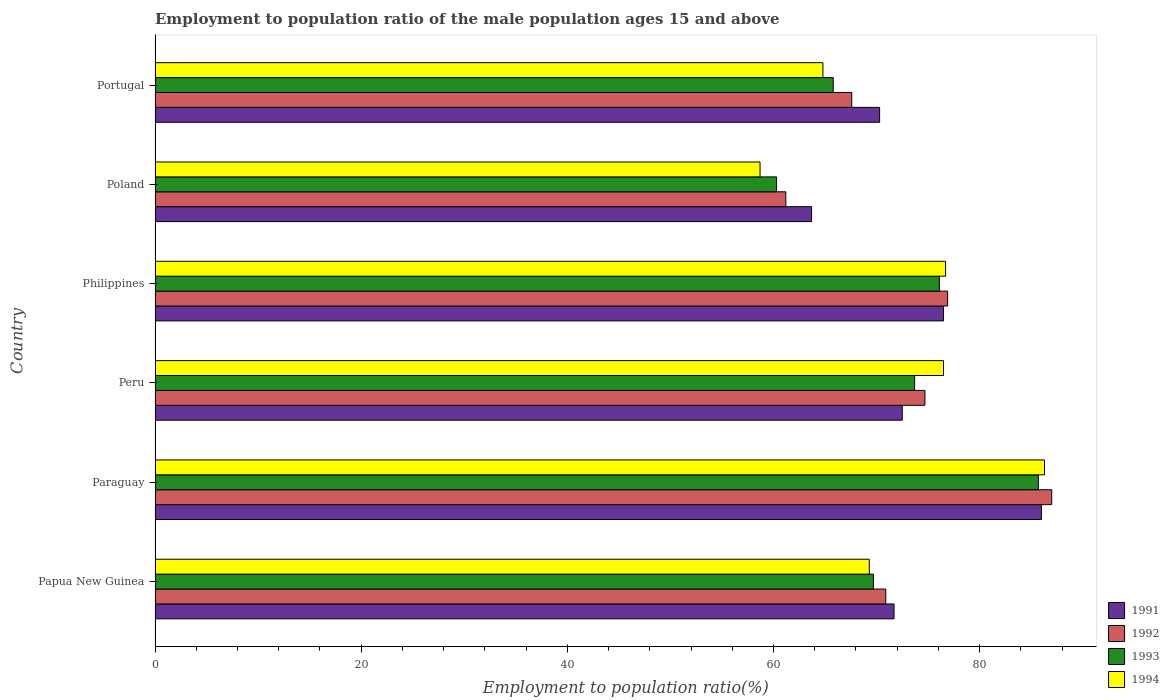How many different coloured bars are there?
Ensure brevity in your answer.  4. How many groups of bars are there?
Offer a terse response. 6. Are the number of bars on each tick of the Y-axis equal?
Offer a terse response. Yes. What is the employment to population ratio in 1993 in Paraguay?
Offer a terse response. 85.7. Across all countries, what is the maximum employment to population ratio in 1994?
Ensure brevity in your answer.  86.3. Across all countries, what is the minimum employment to population ratio in 1994?
Keep it short and to the point. 58.7. In which country was the employment to population ratio in 1991 maximum?
Your answer should be very brief. Paraguay. In which country was the employment to population ratio in 1991 minimum?
Offer a very short reply. Poland. What is the total employment to population ratio in 1991 in the graph?
Offer a terse response. 440.7. What is the difference between the employment to population ratio in 1993 in Papua New Guinea and that in Philippines?
Give a very brief answer. -6.4. What is the difference between the employment to population ratio in 1994 in Paraguay and the employment to population ratio in 1993 in Peru?
Offer a very short reply. 12.6. What is the average employment to population ratio in 1994 per country?
Keep it short and to the point. 72.05. What is the difference between the employment to population ratio in 1993 and employment to population ratio in 1991 in Peru?
Offer a terse response. 1.2. What is the ratio of the employment to population ratio in 1994 in Peru to that in Portugal?
Ensure brevity in your answer.  1.18. Is the difference between the employment to population ratio in 1993 in Papua New Guinea and Poland greater than the difference between the employment to population ratio in 1991 in Papua New Guinea and Poland?
Your response must be concise. Yes. What is the difference between the highest and the second highest employment to population ratio in 1991?
Provide a short and direct response. 9.5. What is the difference between the highest and the lowest employment to population ratio in 1992?
Make the answer very short. 25.8. In how many countries, is the employment to population ratio in 1994 greater than the average employment to population ratio in 1994 taken over all countries?
Provide a succinct answer. 3. Is it the case that in every country, the sum of the employment to population ratio in 1991 and employment to population ratio in 1994 is greater than the sum of employment to population ratio in 1992 and employment to population ratio in 1993?
Ensure brevity in your answer.  No. What does the 1st bar from the bottom in Peru represents?
Provide a short and direct response. 1991. Is it the case that in every country, the sum of the employment to population ratio in 1991 and employment to population ratio in 1993 is greater than the employment to population ratio in 1994?
Offer a terse response. Yes. Does the graph contain any zero values?
Offer a terse response. No. Does the graph contain grids?
Make the answer very short. No. What is the title of the graph?
Offer a terse response. Employment to population ratio of the male population ages 15 and above. What is the label or title of the X-axis?
Your answer should be very brief. Employment to population ratio(%). What is the label or title of the Y-axis?
Provide a short and direct response. Country. What is the Employment to population ratio(%) of 1991 in Papua New Guinea?
Your answer should be compact. 71.7. What is the Employment to population ratio(%) of 1992 in Papua New Guinea?
Offer a very short reply. 70.9. What is the Employment to population ratio(%) of 1993 in Papua New Guinea?
Offer a very short reply. 69.7. What is the Employment to population ratio(%) of 1994 in Papua New Guinea?
Your answer should be very brief. 69.3. What is the Employment to population ratio(%) of 1991 in Paraguay?
Offer a terse response. 86. What is the Employment to population ratio(%) of 1993 in Paraguay?
Your answer should be compact. 85.7. What is the Employment to population ratio(%) of 1994 in Paraguay?
Give a very brief answer. 86.3. What is the Employment to population ratio(%) in 1991 in Peru?
Your response must be concise. 72.5. What is the Employment to population ratio(%) in 1992 in Peru?
Offer a very short reply. 74.7. What is the Employment to population ratio(%) of 1993 in Peru?
Make the answer very short. 73.7. What is the Employment to population ratio(%) of 1994 in Peru?
Make the answer very short. 76.5. What is the Employment to population ratio(%) in 1991 in Philippines?
Offer a terse response. 76.5. What is the Employment to population ratio(%) in 1992 in Philippines?
Offer a very short reply. 76.9. What is the Employment to population ratio(%) of 1993 in Philippines?
Provide a succinct answer. 76.1. What is the Employment to population ratio(%) in 1994 in Philippines?
Offer a very short reply. 76.7. What is the Employment to population ratio(%) of 1991 in Poland?
Ensure brevity in your answer.  63.7. What is the Employment to population ratio(%) of 1992 in Poland?
Offer a very short reply. 61.2. What is the Employment to population ratio(%) of 1993 in Poland?
Keep it short and to the point. 60.3. What is the Employment to population ratio(%) in 1994 in Poland?
Give a very brief answer. 58.7. What is the Employment to population ratio(%) in 1991 in Portugal?
Offer a terse response. 70.3. What is the Employment to population ratio(%) in 1992 in Portugal?
Offer a very short reply. 67.6. What is the Employment to population ratio(%) of 1993 in Portugal?
Provide a succinct answer. 65.8. What is the Employment to population ratio(%) in 1994 in Portugal?
Keep it short and to the point. 64.8. Across all countries, what is the maximum Employment to population ratio(%) in 1991?
Your answer should be compact. 86. Across all countries, what is the maximum Employment to population ratio(%) of 1992?
Your answer should be very brief. 87. Across all countries, what is the maximum Employment to population ratio(%) of 1993?
Provide a succinct answer. 85.7. Across all countries, what is the maximum Employment to population ratio(%) in 1994?
Offer a terse response. 86.3. Across all countries, what is the minimum Employment to population ratio(%) in 1991?
Make the answer very short. 63.7. Across all countries, what is the minimum Employment to population ratio(%) of 1992?
Your answer should be very brief. 61.2. Across all countries, what is the minimum Employment to population ratio(%) in 1993?
Provide a short and direct response. 60.3. Across all countries, what is the minimum Employment to population ratio(%) of 1994?
Give a very brief answer. 58.7. What is the total Employment to population ratio(%) of 1991 in the graph?
Keep it short and to the point. 440.7. What is the total Employment to population ratio(%) in 1992 in the graph?
Give a very brief answer. 438.3. What is the total Employment to population ratio(%) of 1993 in the graph?
Make the answer very short. 431.3. What is the total Employment to population ratio(%) of 1994 in the graph?
Give a very brief answer. 432.3. What is the difference between the Employment to population ratio(%) of 1991 in Papua New Guinea and that in Paraguay?
Offer a terse response. -14.3. What is the difference between the Employment to population ratio(%) of 1992 in Papua New Guinea and that in Paraguay?
Your answer should be very brief. -16.1. What is the difference between the Employment to population ratio(%) of 1993 in Papua New Guinea and that in Paraguay?
Your answer should be compact. -16. What is the difference between the Employment to population ratio(%) of 1991 in Papua New Guinea and that in Peru?
Give a very brief answer. -0.8. What is the difference between the Employment to population ratio(%) of 1994 in Papua New Guinea and that in Peru?
Provide a succinct answer. -7.2. What is the difference between the Employment to population ratio(%) of 1991 in Papua New Guinea and that in Philippines?
Give a very brief answer. -4.8. What is the difference between the Employment to population ratio(%) of 1994 in Papua New Guinea and that in Philippines?
Provide a succinct answer. -7.4. What is the difference between the Employment to population ratio(%) in 1991 in Papua New Guinea and that in Poland?
Provide a succinct answer. 8. What is the difference between the Employment to population ratio(%) of 1993 in Papua New Guinea and that in Poland?
Your response must be concise. 9.4. What is the difference between the Employment to population ratio(%) of 1994 in Papua New Guinea and that in Poland?
Your answer should be compact. 10.6. What is the difference between the Employment to population ratio(%) in 1991 in Papua New Guinea and that in Portugal?
Offer a terse response. 1.4. What is the difference between the Employment to population ratio(%) in 1992 in Papua New Guinea and that in Portugal?
Your response must be concise. 3.3. What is the difference between the Employment to population ratio(%) of 1991 in Paraguay and that in Peru?
Your answer should be compact. 13.5. What is the difference between the Employment to population ratio(%) of 1992 in Paraguay and that in Peru?
Your response must be concise. 12.3. What is the difference between the Employment to population ratio(%) in 1991 in Paraguay and that in Philippines?
Keep it short and to the point. 9.5. What is the difference between the Employment to population ratio(%) of 1991 in Paraguay and that in Poland?
Keep it short and to the point. 22.3. What is the difference between the Employment to population ratio(%) in 1992 in Paraguay and that in Poland?
Offer a very short reply. 25.8. What is the difference between the Employment to population ratio(%) in 1993 in Paraguay and that in Poland?
Give a very brief answer. 25.4. What is the difference between the Employment to population ratio(%) of 1994 in Paraguay and that in Poland?
Your response must be concise. 27.6. What is the difference between the Employment to population ratio(%) of 1993 in Paraguay and that in Portugal?
Your answer should be compact. 19.9. What is the difference between the Employment to population ratio(%) in 1994 in Paraguay and that in Portugal?
Ensure brevity in your answer.  21.5. What is the difference between the Employment to population ratio(%) of 1991 in Peru and that in Philippines?
Offer a terse response. -4. What is the difference between the Employment to population ratio(%) in 1991 in Peru and that in Poland?
Keep it short and to the point. 8.8. What is the difference between the Employment to population ratio(%) of 1992 in Peru and that in Poland?
Your answer should be very brief. 13.5. What is the difference between the Employment to population ratio(%) in 1991 in Peru and that in Portugal?
Your response must be concise. 2.2. What is the difference between the Employment to population ratio(%) of 1994 in Peru and that in Portugal?
Your response must be concise. 11.7. What is the difference between the Employment to population ratio(%) of 1991 in Philippines and that in Portugal?
Provide a succinct answer. 6.2. What is the difference between the Employment to population ratio(%) in 1993 in Philippines and that in Portugal?
Ensure brevity in your answer.  10.3. What is the difference between the Employment to population ratio(%) in 1993 in Poland and that in Portugal?
Offer a terse response. -5.5. What is the difference between the Employment to population ratio(%) of 1991 in Papua New Guinea and the Employment to population ratio(%) of 1992 in Paraguay?
Provide a short and direct response. -15.3. What is the difference between the Employment to population ratio(%) in 1991 in Papua New Guinea and the Employment to population ratio(%) in 1993 in Paraguay?
Provide a short and direct response. -14. What is the difference between the Employment to population ratio(%) of 1991 in Papua New Guinea and the Employment to population ratio(%) of 1994 in Paraguay?
Provide a short and direct response. -14.6. What is the difference between the Employment to population ratio(%) of 1992 in Papua New Guinea and the Employment to population ratio(%) of 1993 in Paraguay?
Your answer should be compact. -14.8. What is the difference between the Employment to population ratio(%) in 1992 in Papua New Guinea and the Employment to population ratio(%) in 1994 in Paraguay?
Provide a short and direct response. -15.4. What is the difference between the Employment to population ratio(%) of 1993 in Papua New Guinea and the Employment to population ratio(%) of 1994 in Paraguay?
Your answer should be very brief. -16.6. What is the difference between the Employment to population ratio(%) in 1991 in Papua New Guinea and the Employment to population ratio(%) in 1992 in Peru?
Your response must be concise. -3. What is the difference between the Employment to population ratio(%) of 1992 in Papua New Guinea and the Employment to population ratio(%) of 1994 in Peru?
Your answer should be compact. -5.6. What is the difference between the Employment to population ratio(%) of 1993 in Papua New Guinea and the Employment to population ratio(%) of 1994 in Peru?
Give a very brief answer. -6.8. What is the difference between the Employment to population ratio(%) in 1991 in Papua New Guinea and the Employment to population ratio(%) in 1993 in Philippines?
Your response must be concise. -4.4. What is the difference between the Employment to population ratio(%) of 1991 in Papua New Guinea and the Employment to population ratio(%) of 1992 in Poland?
Offer a very short reply. 10.5. What is the difference between the Employment to population ratio(%) in 1992 in Papua New Guinea and the Employment to population ratio(%) in 1993 in Poland?
Give a very brief answer. 10.6. What is the difference between the Employment to population ratio(%) in 1991 in Papua New Guinea and the Employment to population ratio(%) in 1993 in Portugal?
Provide a short and direct response. 5.9. What is the difference between the Employment to population ratio(%) of 1991 in Papua New Guinea and the Employment to population ratio(%) of 1994 in Portugal?
Offer a terse response. 6.9. What is the difference between the Employment to population ratio(%) of 1992 in Papua New Guinea and the Employment to population ratio(%) of 1994 in Portugal?
Your response must be concise. 6.1. What is the difference between the Employment to population ratio(%) in 1991 in Paraguay and the Employment to population ratio(%) in 1992 in Peru?
Give a very brief answer. 11.3. What is the difference between the Employment to population ratio(%) in 1991 in Paraguay and the Employment to population ratio(%) in 1993 in Peru?
Your answer should be compact. 12.3. What is the difference between the Employment to population ratio(%) in 1992 in Paraguay and the Employment to population ratio(%) in 1994 in Peru?
Offer a terse response. 10.5. What is the difference between the Employment to population ratio(%) of 1991 in Paraguay and the Employment to population ratio(%) of 1992 in Philippines?
Provide a short and direct response. 9.1. What is the difference between the Employment to population ratio(%) in 1991 in Paraguay and the Employment to population ratio(%) in 1993 in Philippines?
Offer a terse response. 9.9. What is the difference between the Employment to population ratio(%) of 1991 in Paraguay and the Employment to population ratio(%) of 1994 in Philippines?
Provide a succinct answer. 9.3. What is the difference between the Employment to population ratio(%) of 1992 in Paraguay and the Employment to population ratio(%) of 1993 in Philippines?
Your response must be concise. 10.9. What is the difference between the Employment to population ratio(%) of 1992 in Paraguay and the Employment to population ratio(%) of 1994 in Philippines?
Offer a terse response. 10.3. What is the difference between the Employment to population ratio(%) in 1993 in Paraguay and the Employment to population ratio(%) in 1994 in Philippines?
Give a very brief answer. 9. What is the difference between the Employment to population ratio(%) in 1991 in Paraguay and the Employment to population ratio(%) in 1992 in Poland?
Your response must be concise. 24.8. What is the difference between the Employment to population ratio(%) in 1991 in Paraguay and the Employment to population ratio(%) in 1993 in Poland?
Ensure brevity in your answer.  25.7. What is the difference between the Employment to population ratio(%) in 1991 in Paraguay and the Employment to population ratio(%) in 1994 in Poland?
Offer a terse response. 27.3. What is the difference between the Employment to population ratio(%) of 1992 in Paraguay and the Employment to population ratio(%) of 1993 in Poland?
Your response must be concise. 26.7. What is the difference between the Employment to population ratio(%) in 1992 in Paraguay and the Employment to population ratio(%) in 1994 in Poland?
Keep it short and to the point. 28.3. What is the difference between the Employment to population ratio(%) of 1993 in Paraguay and the Employment to population ratio(%) of 1994 in Poland?
Give a very brief answer. 27. What is the difference between the Employment to population ratio(%) of 1991 in Paraguay and the Employment to population ratio(%) of 1993 in Portugal?
Offer a terse response. 20.2. What is the difference between the Employment to population ratio(%) in 1991 in Paraguay and the Employment to population ratio(%) in 1994 in Portugal?
Give a very brief answer. 21.2. What is the difference between the Employment to population ratio(%) of 1992 in Paraguay and the Employment to population ratio(%) of 1993 in Portugal?
Offer a very short reply. 21.2. What is the difference between the Employment to population ratio(%) of 1993 in Paraguay and the Employment to population ratio(%) of 1994 in Portugal?
Make the answer very short. 20.9. What is the difference between the Employment to population ratio(%) of 1991 in Peru and the Employment to population ratio(%) of 1994 in Philippines?
Provide a succinct answer. -4.2. What is the difference between the Employment to population ratio(%) of 1992 in Peru and the Employment to population ratio(%) of 1994 in Philippines?
Keep it short and to the point. -2. What is the difference between the Employment to population ratio(%) in 1991 in Peru and the Employment to population ratio(%) in 1993 in Poland?
Provide a short and direct response. 12.2. What is the difference between the Employment to population ratio(%) in 1991 in Peru and the Employment to population ratio(%) in 1994 in Poland?
Provide a short and direct response. 13.8. What is the difference between the Employment to population ratio(%) in 1992 in Peru and the Employment to population ratio(%) in 1994 in Poland?
Your answer should be very brief. 16. What is the difference between the Employment to population ratio(%) of 1993 in Peru and the Employment to population ratio(%) of 1994 in Poland?
Offer a terse response. 15. What is the difference between the Employment to population ratio(%) in 1991 in Peru and the Employment to population ratio(%) in 1992 in Portugal?
Offer a very short reply. 4.9. What is the difference between the Employment to population ratio(%) of 1991 in Peru and the Employment to population ratio(%) of 1994 in Portugal?
Make the answer very short. 7.7. What is the difference between the Employment to population ratio(%) in 1993 in Peru and the Employment to population ratio(%) in 1994 in Portugal?
Make the answer very short. 8.9. What is the difference between the Employment to population ratio(%) of 1991 in Philippines and the Employment to population ratio(%) of 1993 in Poland?
Offer a very short reply. 16.2. What is the difference between the Employment to population ratio(%) in 1991 in Philippines and the Employment to population ratio(%) in 1994 in Poland?
Keep it short and to the point. 17.8. What is the difference between the Employment to population ratio(%) of 1992 in Philippines and the Employment to population ratio(%) of 1993 in Poland?
Provide a short and direct response. 16.6. What is the difference between the Employment to population ratio(%) of 1992 in Philippines and the Employment to population ratio(%) of 1994 in Poland?
Make the answer very short. 18.2. What is the difference between the Employment to population ratio(%) in 1991 in Philippines and the Employment to population ratio(%) in 1992 in Portugal?
Ensure brevity in your answer.  8.9. What is the difference between the Employment to population ratio(%) in 1991 in Philippines and the Employment to population ratio(%) in 1993 in Portugal?
Keep it short and to the point. 10.7. What is the difference between the Employment to population ratio(%) of 1991 in Philippines and the Employment to population ratio(%) of 1994 in Portugal?
Provide a succinct answer. 11.7. What is the difference between the Employment to population ratio(%) of 1992 in Philippines and the Employment to population ratio(%) of 1994 in Portugal?
Your answer should be compact. 12.1. What is the difference between the Employment to population ratio(%) in 1993 in Philippines and the Employment to population ratio(%) in 1994 in Portugal?
Provide a succinct answer. 11.3. What is the difference between the Employment to population ratio(%) of 1991 in Poland and the Employment to population ratio(%) of 1992 in Portugal?
Offer a terse response. -3.9. What is the difference between the Employment to population ratio(%) of 1991 in Poland and the Employment to population ratio(%) of 1994 in Portugal?
Offer a terse response. -1.1. What is the difference between the Employment to population ratio(%) of 1992 in Poland and the Employment to population ratio(%) of 1994 in Portugal?
Offer a terse response. -3.6. What is the average Employment to population ratio(%) in 1991 per country?
Offer a terse response. 73.45. What is the average Employment to population ratio(%) in 1992 per country?
Give a very brief answer. 73.05. What is the average Employment to population ratio(%) in 1993 per country?
Make the answer very short. 71.88. What is the average Employment to population ratio(%) of 1994 per country?
Make the answer very short. 72.05. What is the difference between the Employment to population ratio(%) in 1991 and Employment to population ratio(%) in 1992 in Papua New Guinea?
Your response must be concise. 0.8. What is the difference between the Employment to population ratio(%) in 1991 and Employment to population ratio(%) in 1994 in Papua New Guinea?
Your response must be concise. 2.4. What is the difference between the Employment to population ratio(%) of 1992 and Employment to population ratio(%) of 1993 in Papua New Guinea?
Offer a terse response. 1.2. What is the difference between the Employment to population ratio(%) of 1993 and Employment to population ratio(%) of 1994 in Papua New Guinea?
Your response must be concise. 0.4. What is the difference between the Employment to population ratio(%) of 1991 and Employment to population ratio(%) of 1992 in Paraguay?
Offer a very short reply. -1. What is the difference between the Employment to population ratio(%) of 1991 and Employment to population ratio(%) of 1993 in Paraguay?
Provide a succinct answer. 0.3. What is the difference between the Employment to population ratio(%) in 1991 and Employment to population ratio(%) in 1994 in Paraguay?
Offer a terse response. -0.3. What is the difference between the Employment to population ratio(%) in 1992 and Employment to population ratio(%) in 1993 in Paraguay?
Offer a terse response. 1.3. What is the difference between the Employment to population ratio(%) in 1992 and Employment to population ratio(%) in 1994 in Paraguay?
Provide a succinct answer. 0.7. What is the difference between the Employment to population ratio(%) in 1993 and Employment to population ratio(%) in 1994 in Paraguay?
Your response must be concise. -0.6. What is the difference between the Employment to population ratio(%) in 1991 and Employment to population ratio(%) in 1992 in Peru?
Ensure brevity in your answer.  -2.2. What is the difference between the Employment to population ratio(%) of 1991 and Employment to population ratio(%) of 1994 in Peru?
Make the answer very short. -4. What is the difference between the Employment to population ratio(%) in 1991 and Employment to population ratio(%) in 1992 in Philippines?
Your response must be concise. -0.4. What is the difference between the Employment to population ratio(%) in 1991 and Employment to population ratio(%) in 1993 in Philippines?
Offer a very short reply. 0.4. What is the difference between the Employment to population ratio(%) in 1992 and Employment to population ratio(%) in 1994 in Philippines?
Provide a succinct answer. 0.2. What is the difference between the Employment to population ratio(%) of 1993 and Employment to population ratio(%) of 1994 in Philippines?
Ensure brevity in your answer.  -0.6. What is the difference between the Employment to population ratio(%) in 1991 and Employment to population ratio(%) in 1992 in Poland?
Keep it short and to the point. 2.5. What is the difference between the Employment to population ratio(%) in 1991 and Employment to population ratio(%) in 1994 in Poland?
Make the answer very short. 5. What is the difference between the Employment to population ratio(%) in 1991 and Employment to population ratio(%) in 1992 in Portugal?
Provide a succinct answer. 2.7. What is the difference between the Employment to population ratio(%) of 1991 and Employment to population ratio(%) of 1993 in Portugal?
Provide a succinct answer. 4.5. What is the difference between the Employment to population ratio(%) of 1992 and Employment to population ratio(%) of 1994 in Portugal?
Your response must be concise. 2.8. What is the difference between the Employment to population ratio(%) of 1993 and Employment to population ratio(%) of 1994 in Portugal?
Offer a very short reply. 1. What is the ratio of the Employment to population ratio(%) in 1991 in Papua New Guinea to that in Paraguay?
Provide a succinct answer. 0.83. What is the ratio of the Employment to population ratio(%) in 1992 in Papua New Guinea to that in Paraguay?
Provide a short and direct response. 0.81. What is the ratio of the Employment to population ratio(%) in 1993 in Papua New Guinea to that in Paraguay?
Ensure brevity in your answer.  0.81. What is the ratio of the Employment to population ratio(%) of 1994 in Papua New Guinea to that in Paraguay?
Provide a short and direct response. 0.8. What is the ratio of the Employment to population ratio(%) in 1991 in Papua New Guinea to that in Peru?
Provide a succinct answer. 0.99. What is the ratio of the Employment to population ratio(%) in 1992 in Papua New Guinea to that in Peru?
Keep it short and to the point. 0.95. What is the ratio of the Employment to population ratio(%) of 1993 in Papua New Guinea to that in Peru?
Make the answer very short. 0.95. What is the ratio of the Employment to population ratio(%) in 1994 in Papua New Guinea to that in Peru?
Make the answer very short. 0.91. What is the ratio of the Employment to population ratio(%) in 1991 in Papua New Guinea to that in Philippines?
Your response must be concise. 0.94. What is the ratio of the Employment to population ratio(%) in 1992 in Papua New Guinea to that in Philippines?
Your answer should be very brief. 0.92. What is the ratio of the Employment to population ratio(%) of 1993 in Papua New Guinea to that in Philippines?
Your answer should be very brief. 0.92. What is the ratio of the Employment to population ratio(%) of 1994 in Papua New Guinea to that in Philippines?
Keep it short and to the point. 0.9. What is the ratio of the Employment to population ratio(%) of 1991 in Papua New Guinea to that in Poland?
Offer a terse response. 1.13. What is the ratio of the Employment to population ratio(%) of 1992 in Papua New Guinea to that in Poland?
Provide a short and direct response. 1.16. What is the ratio of the Employment to population ratio(%) in 1993 in Papua New Guinea to that in Poland?
Your response must be concise. 1.16. What is the ratio of the Employment to population ratio(%) in 1994 in Papua New Guinea to that in Poland?
Provide a succinct answer. 1.18. What is the ratio of the Employment to population ratio(%) of 1991 in Papua New Guinea to that in Portugal?
Your answer should be very brief. 1.02. What is the ratio of the Employment to population ratio(%) in 1992 in Papua New Guinea to that in Portugal?
Provide a short and direct response. 1.05. What is the ratio of the Employment to population ratio(%) in 1993 in Papua New Guinea to that in Portugal?
Your response must be concise. 1.06. What is the ratio of the Employment to population ratio(%) in 1994 in Papua New Guinea to that in Portugal?
Your answer should be very brief. 1.07. What is the ratio of the Employment to population ratio(%) in 1991 in Paraguay to that in Peru?
Your answer should be compact. 1.19. What is the ratio of the Employment to population ratio(%) of 1992 in Paraguay to that in Peru?
Provide a short and direct response. 1.16. What is the ratio of the Employment to population ratio(%) in 1993 in Paraguay to that in Peru?
Your response must be concise. 1.16. What is the ratio of the Employment to population ratio(%) of 1994 in Paraguay to that in Peru?
Make the answer very short. 1.13. What is the ratio of the Employment to population ratio(%) in 1991 in Paraguay to that in Philippines?
Keep it short and to the point. 1.12. What is the ratio of the Employment to population ratio(%) of 1992 in Paraguay to that in Philippines?
Your answer should be compact. 1.13. What is the ratio of the Employment to population ratio(%) in 1993 in Paraguay to that in Philippines?
Provide a short and direct response. 1.13. What is the ratio of the Employment to population ratio(%) of 1994 in Paraguay to that in Philippines?
Ensure brevity in your answer.  1.13. What is the ratio of the Employment to population ratio(%) in 1991 in Paraguay to that in Poland?
Provide a short and direct response. 1.35. What is the ratio of the Employment to population ratio(%) of 1992 in Paraguay to that in Poland?
Make the answer very short. 1.42. What is the ratio of the Employment to population ratio(%) of 1993 in Paraguay to that in Poland?
Your response must be concise. 1.42. What is the ratio of the Employment to population ratio(%) in 1994 in Paraguay to that in Poland?
Offer a very short reply. 1.47. What is the ratio of the Employment to population ratio(%) of 1991 in Paraguay to that in Portugal?
Ensure brevity in your answer.  1.22. What is the ratio of the Employment to population ratio(%) in 1992 in Paraguay to that in Portugal?
Your answer should be very brief. 1.29. What is the ratio of the Employment to population ratio(%) of 1993 in Paraguay to that in Portugal?
Give a very brief answer. 1.3. What is the ratio of the Employment to population ratio(%) of 1994 in Paraguay to that in Portugal?
Provide a short and direct response. 1.33. What is the ratio of the Employment to population ratio(%) in 1991 in Peru to that in Philippines?
Your answer should be very brief. 0.95. What is the ratio of the Employment to population ratio(%) in 1992 in Peru to that in Philippines?
Make the answer very short. 0.97. What is the ratio of the Employment to population ratio(%) in 1993 in Peru to that in Philippines?
Give a very brief answer. 0.97. What is the ratio of the Employment to population ratio(%) of 1991 in Peru to that in Poland?
Your answer should be compact. 1.14. What is the ratio of the Employment to population ratio(%) in 1992 in Peru to that in Poland?
Your answer should be very brief. 1.22. What is the ratio of the Employment to population ratio(%) of 1993 in Peru to that in Poland?
Your answer should be compact. 1.22. What is the ratio of the Employment to population ratio(%) in 1994 in Peru to that in Poland?
Ensure brevity in your answer.  1.3. What is the ratio of the Employment to population ratio(%) of 1991 in Peru to that in Portugal?
Offer a terse response. 1.03. What is the ratio of the Employment to population ratio(%) of 1992 in Peru to that in Portugal?
Your response must be concise. 1.1. What is the ratio of the Employment to population ratio(%) of 1993 in Peru to that in Portugal?
Provide a short and direct response. 1.12. What is the ratio of the Employment to population ratio(%) in 1994 in Peru to that in Portugal?
Provide a succinct answer. 1.18. What is the ratio of the Employment to population ratio(%) in 1991 in Philippines to that in Poland?
Offer a very short reply. 1.2. What is the ratio of the Employment to population ratio(%) in 1992 in Philippines to that in Poland?
Ensure brevity in your answer.  1.26. What is the ratio of the Employment to population ratio(%) of 1993 in Philippines to that in Poland?
Offer a very short reply. 1.26. What is the ratio of the Employment to population ratio(%) of 1994 in Philippines to that in Poland?
Your answer should be compact. 1.31. What is the ratio of the Employment to population ratio(%) in 1991 in Philippines to that in Portugal?
Keep it short and to the point. 1.09. What is the ratio of the Employment to population ratio(%) in 1992 in Philippines to that in Portugal?
Provide a succinct answer. 1.14. What is the ratio of the Employment to population ratio(%) of 1993 in Philippines to that in Portugal?
Offer a terse response. 1.16. What is the ratio of the Employment to population ratio(%) of 1994 in Philippines to that in Portugal?
Offer a very short reply. 1.18. What is the ratio of the Employment to population ratio(%) in 1991 in Poland to that in Portugal?
Make the answer very short. 0.91. What is the ratio of the Employment to population ratio(%) of 1992 in Poland to that in Portugal?
Keep it short and to the point. 0.91. What is the ratio of the Employment to population ratio(%) in 1993 in Poland to that in Portugal?
Offer a very short reply. 0.92. What is the ratio of the Employment to population ratio(%) of 1994 in Poland to that in Portugal?
Provide a succinct answer. 0.91. What is the difference between the highest and the second highest Employment to population ratio(%) of 1992?
Provide a short and direct response. 10.1. What is the difference between the highest and the second highest Employment to population ratio(%) in 1993?
Make the answer very short. 9.6. What is the difference between the highest and the second highest Employment to population ratio(%) of 1994?
Provide a succinct answer. 9.6. What is the difference between the highest and the lowest Employment to population ratio(%) in 1991?
Make the answer very short. 22.3. What is the difference between the highest and the lowest Employment to population ratio(%) in 1992?
Keep it short and to the point. 25.8. What is the difference between the highest and the lowest Employment to population ratio(%) in 1993?
Ensure brevity in your answer.  25.4. What is the difference between the highest and the lowest Employment to population ratio(%) of 1994?
Your response must be concise. 27.6. 